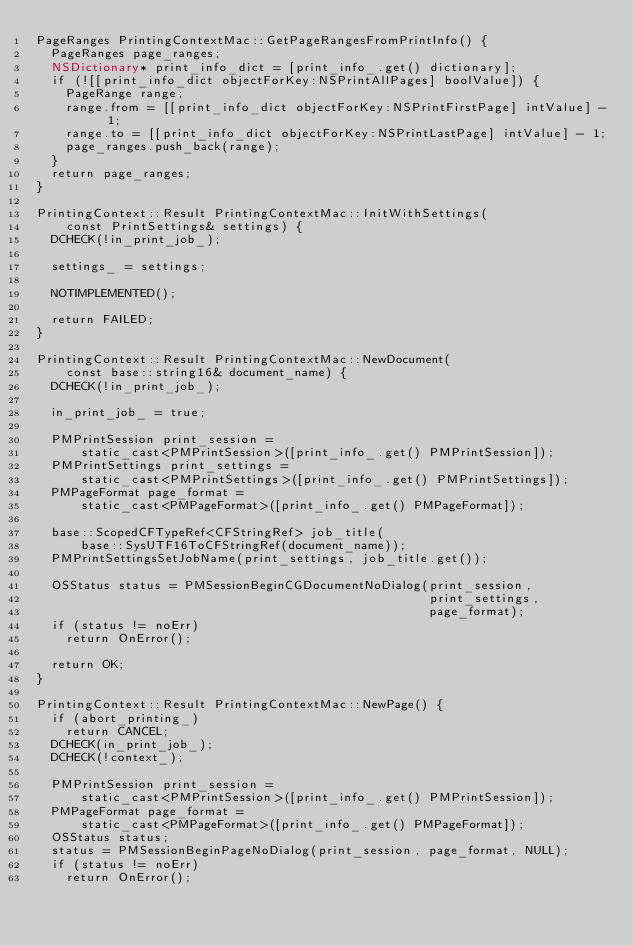<code> <loc_0><loc_0><loc_500><loc_500><_ObjectiveC_>PageRanges PrintingContextMac::GetPageRangesFromPrintInfo() {
  PageRanges page_ranges;
  NSDictionary* print_info_dict = [print_info_.get() dictionary];
  if (![[print_info_dict objectForKey:NSPrintAllPages] boolValue]) {
    PageRange range;
    range.from = [[print_info_dict objectForKey:NSPrintFirstPage] intValue] - 1;
    range.to = [[print_info_dict objectForKey:NSPrintLastPage] intValue] - 1;
    page_ranges.push_back(range);
  }
  return page_ranges;
}

PrintingContext::Result PrintingContextMac::InitWithSettings(
    const PrintSettings& settings) {
  DCHECK(!in_print_job_);

  settings_ = settings;

  NOTIMPLEMENTED();

  return FAILED;
}

PrintingContext::Result PrintingContextMac::NewDocument(
    const base::string16& document_name) {
  DCHECK(!in_print_job_);

  in_print_job_ = true;

  PMPrintSession print_session =
      static_cast<PMPrintSession>([print_info_.get() PMPrintSession]);
  PMPrintSettings print_settings =
      static_cast<PMPrintSettings>([print_info_.get() PMPrintSettings]);
  PMPageFormat page_format =
      static_cast<PMPageFormat>([print_info_.get() PMPageFormat]);

  base::ScopedCFTypeRef<CFStringRef> job_title(
      base::SysUTF16ToCFStringRef(document_name));
  PMPrintSettingsSetJobName(print_settings, job_title.get());

  OSStatus status = PMSessionBeginCGDocumentNoDialog(print_session,
                                                     print_settings,
                                                     page_format);
  if (status != noErr)
    return OnError();

  return OK;
}

PrintingContext::Result PrintingContextMac::NewPage() {
  if (abort_printing_)
    return CANCEL;
  DCHECK(in_print_job_);
  DCHECK(!context_);

  PMPrintSession print_session =
      static_cast<PMPrintSession>([print_info_.get() PMPrintSession]);
  PMPageFormat page_format =
      static_cast<PMPageFormat>([print_info_.get() PMPageFormat]);
  OSStatus status;
  status = PMSessionBeginPageNoDialog(print_session, page_format, NULL);
  if (status != noErr)
    return OnError();</code> 